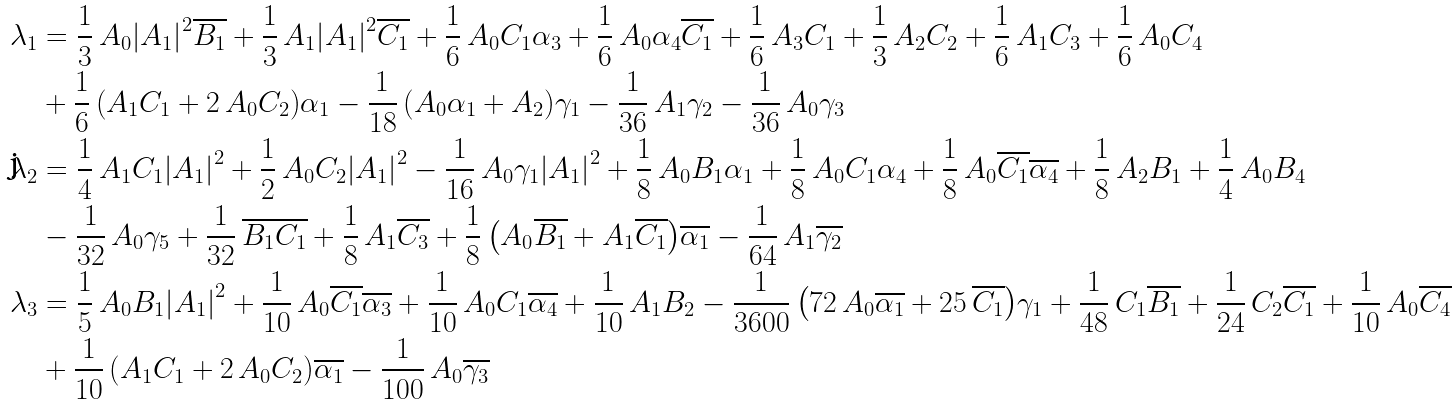Convert formula to latex. <formula><loc_0><loc_0><loc_500><loc_500>\lambda _ { 1 } & = \frac { 1 } { 3 } \, A _ { 0 } { \left | A _ { 1 } \right | } ^ { 2 } \overline { B _ { 1 } } + \frac { 1 } { 3 } \, A _ { 1 } { \left | A _ { 1 } \right | } ^ { 2 } \overline { C _ { 1 } } + \frac { 1 } { 6 } \, A _ { 0 } C _ { 1 } \alpha _ { 3 } + \frac { 1 } { 6 } \, A _ { 0 } \alpha _ { 4 } \overline { C _ { 1 } } + \frac { 1 } { 6 } \, A _ { 3 } C _ { 1 } + \frac { 1 } { 3 } \, A _ { 2 } C _ { 2 } + \frac { 1 } { 6 } \, A _ { 1 } C _ { 3 } + \frac { 1 } { 6 } \, A _ { 0 } C _ { 4 } \\ & + \frac { 1 } { 6 } \, { \left ( A _ { 1 } C _ { 1 } + 2 \, A _ { 0 } C _ { 2 } \right ) } \alpha _ { 1 } - \frac { 1 } { 1 8 } \, { \left ( A _ { 0 } \alpha _ { 1 } + A _ { 2 } \right ) } \gamma _ { 1 } - \frac { 1 } { 3 6 } \, A _ { 1 } \gamma _ { 2 } - \frac { 1 } { 3 6 } \, A _ { 0 } \gamma _ { 3 } \\ \lambda _ { 2 } & = \frac { 1 } { 4 } \, A _ { 1 } C _ { 1 } { \left | A _ { 1 } \right | } ^ { 2 } + \frac { 1 } { 2 } \, A _ { 0 } C _ { 2 } { \left | A _ { 1 } \right | } ^ { 2 } - \frac { 1 } { 1 6 } \, A _ { 0 } \gamma _ { 1 } { \left | A _ { 1 } \right | } ^ { 2 } + \frac { 1 } { 8 } \, A _ { 0 } B _ { 1 } \alpha _ { 1 } + \frac { 1 } { 8 } \, A _ { 0 } C _ { 1 } \alpha _ { 4 } + \frac { 1 } { 8 } \, A _ { 0 } \overline { C _ { 1 } } \overline { \alpha _ { 4 } } + \frac { 1 } { 8 } \, A _ { 2 } B _ { 1 } + \frac { 1 } { 4 } \, A _ { 0 } B _ { 4 } \\ & - \frac { 1 } { 3 2 } \, A _ { 0 } \gamma _ { 5 } + \frac { 1 } { 3 2 } \, \overline { B _ { 1 } } \overline { C _ { 1 } } + \frac { 1 } { 8 } \, A _ { 1 } \overline { C _ { 3 } } + \frac { 1 } { 8 } \, { \left ( A _ { 0 } \overline { B _ { 1 } } + A _ { 1 } \overline { C _ { 1 } } \right ) } \overline { \alpha _ { 1 } } - \frac { 1 } { 6 4 } \, A _ { 1 } \overline { \gamma _ { 2 } } \\ \lambda _ { 3 } & = \frac { 1 } { 5 } \, A _ { 0 } B _ { 1 } { \left | A _ { 1 } \right | } ^ { 2 } + \frac { 1 } { 1 0 } \, A _ { 0 } \overline { C _ { 1 } } \overline { \alpha _ { 3 } } + \frac { 1 } { 1 0 } \, A _ { 0 } C _ { 1 } \overline { \alpha _ { 4 } } + \frac { 1 } { 1 0 } \, A _ { 1 } B _ { 2 } - \frac { 1 } { 3 6 0 0 } \, { \left ( 7 2 \, A _ { 0 } \overline { \alpha _ { 1 } } + 2 5 \, \overline { C _ { 1 } } \right ) } \gamma _ { 1 } + \frac { 1 } { 4 8 } \, C _ { 1 } \overline { B _ { 1 } } + \frac { 1 } { 2 4 } \, C _ { 2 } \overline { C _ { 1 } } + \frac { 1 } { 1 0 } \, A _ { 0 } \overline { C _ { 4 } } \\ & + \frac { 1 } { 1 0 } \, { \left ( A _ { 1 } C _ { 1 } + 2 \, A _ { 0 } C _ { 2 } \right ) } \overline { \alpha _ { 1 } } - \frac { 1 } { 1 0 0 } \, A _ { 0 } \overline { \gamma _ { 3 } }</formula> 